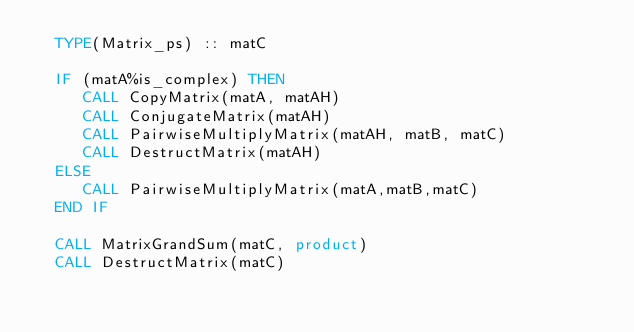<code> <loc_0><loc_0><loc_500><loc_500><_FORTRAN_>  TYPE(Matrix_ps) :: matC

  IF (matA%is_complex) THEN
     CALL CopyMatrix(matA, matAH)
     CALL ConjugateMatrix(matAH)
     CALL PairwiseMultiplyMatrix(matAH, matB, matC)
     CALL DestructMatrix(matAH)
  ELSE
     CALL PairwiseMultiplyMatrix(matA,matB,matC)
  END IF

  CALL MatrixGrandSum(matC, product)
  CALL DestructMatrix(matC)
</code> 